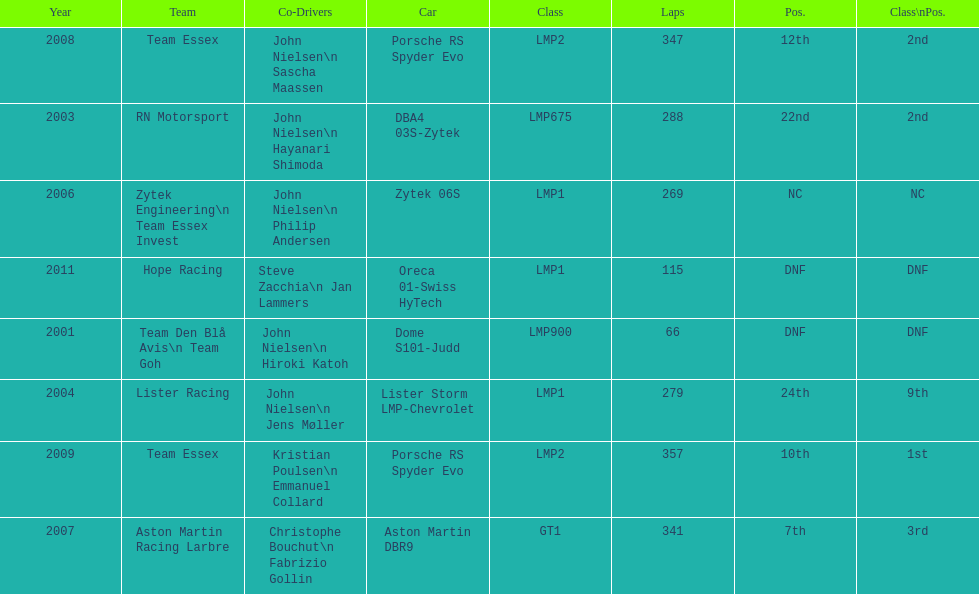Who was casper elgaard's co-driver the most often for the 24 hours of le mans? John Nielsen. 